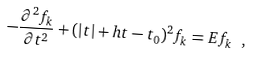Convert formula to latex. <formula><loc_0><loc_0><loc_500><loc_500>- \frac { \partial ^ { 2 } f _ { k } } { \partial t ^ { 2 } } + ( | t | + h t - t _ { 0 } ) ^ { 2 } f _ { k } = E f _ { k } \ ,</formula> 